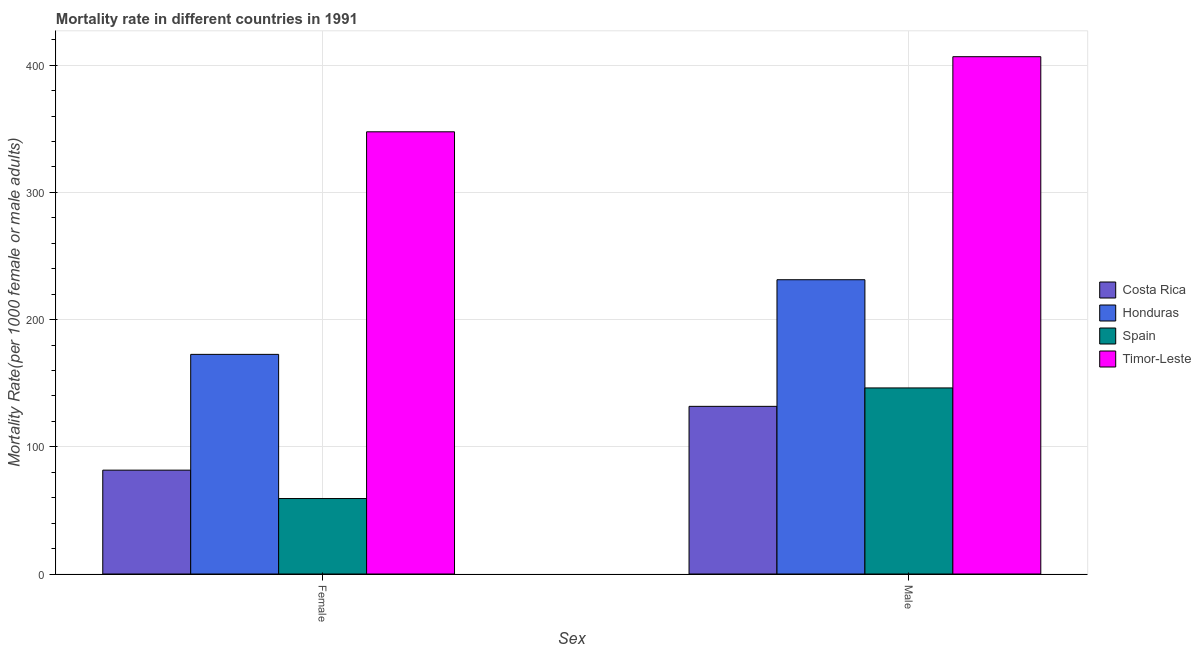How many groups of bars are there?
Your answer should be compact. 2. Are the number of bars on each tick of the X-axis equal?
Your response must be concise. Yes. How many bars are there on the 1st tick from the left?
Provide a succinct answer. 4. What is the male mortality rate in Costa Rica?
Make the answer very short. 131.81. Across all countries, what is the maximum female mortality rate?
Offer a very short reply. 347.65. Across all countries, what is the minimum female mortality rate?
Make the answer very short. 59.33. In which country was the male mortality rate maximum?
Your answer should be very brief. Timor-Leste. In which country was the male mortality rate minimum?
Your answer should be very brief. Costa Rica. What is the total male mortality rate in the graph?
Provide a succinct answer. 916.15. What is the difference between the female mortality rate in Spain and that in Honduras?
Keep it short and to the point. -113.35. What is the difference between the female mortality rate in Costa Rica and the male mortality rate in Spain?
Keep it short and to the point. -64.63. What is the average male mortality rate per country?
Make the answer very short. 229.04. What is the difference between the male mortality rate and female mortality rate in Costa Rica?
Your answer should be compact. 50.15. In how many countries, is the male mortality rate greater than 100 ?
Your response must be concise. 4. What is the ratio of the male mortality rate in Costa Rica to that in Honduras?
Offer a very short reply. 0.57. Is the female mortality rate in Timor-Leste less than that in Spain?
Your response must be concise. No. In how many countries, is the male mortality rate greater than the average male mortality rate taken over all countries?
Your response must be concise. 2. What does the 3rd bar from the right in Male represents?
Make the answer very short. Honduras. How many countries are there in the graph?
Offer a very short reply. 4. What is the difference between two consecutive major ticks on the Y-axis?
Keep it short and to the point. 100. Are the values on the major ticks of Y-axis written in scientific E-notation?
Your answer should be very brief. No. Does the graph contain grids?
Provide a short and direct response. Yes. How are the legend labels stacked?
Offer a terse response. Vertical. What is the title of the graph?
Your answer should be compact. Mortality rate in different countries in 1991. What is the label or title of the X-axis?
Offer a terse response. Sex. What is the label or title of the Y-axis?
Your answer should be very brief. Mortality Rate(per 1000 female or male adults). What is the Mortality Rate(per 1000 female or male adults) of Costa Rica in Female?
Provide a succinct answer. 81.65. What is the Mortality Rate(per 1000 female or male adults) in Honduras in Female?
Give a very brief answer. 172.67. What is the Mortality Rate(per 1000 female or male adults) in Spain in Female?
Your answer should be compact. 59.33. What is the Mortality Rate(per 1000 female or male adults) in Timor-Leste in Female?
Ensure brevity in your answer.  347.65. What is the Mortality Rate(per 1000 female or male adults) of Costa Rica in Male?
Offer a terse response. 131.81. What is the Mortality Rate(per 1000 female or male adults) in Honduras in Male?
Keep it short and to the point. 231.35. What is the Mortality Rate(per 1000 female or male adults) of Spain in Male?
Your response must be concise. 146.28. What is the Mortality Rate(per 1000 female or male adults) of Timor-Leste in Male?
Your response must be concise. 406.7. Across all Sex, what is the maximum Mortality Rate(per 1000 female or male adults) in Costa Rica?
Provide a succinct answer. 131.81. Across all Sex, what is the maximum Mortality Rate(per 1000 female or male adults) of Honduras?
Keep it short and to the point. 231.35. Across all Sex, what is the maximum Mortality Rate(per 1000 female or male adults) of Spain?
Ensure brevity in your answer.  146.28. Across all Sex, what is the maximum Mortality Rate(per 1000 female or male adults) in Timor-Leste?
Your answer should be compact. 406.7. Across all Sex, what is the minimum Mortality Rate(per 1000 female or male adults) of Costa Rica?
Ensure brevity in your answer.  81.65. Across all Sex, what is the minimum Mortality Rate(per 1000 female or male adults) of Honduras?
Your answer should be very brief. 172.67. Across all Sex, what is the minimum Mortality Rate(per 1000 female or male adults) in Spain?
Keep it short and to the point. 59.33. Across all Sex, what is the minimum Mortality Rate(per 1000 female or male adults) of Timor-Leste?
Your answer should be compact. 347.65. What is the total Mortality Rate(per 1000 female or male adults) of Costa Rica in the graph?
Your answer should be very brief. 213.46. What is the total Mortality Rate(per 1000 female or male adults) of Honduras in the graph?
Give a very brief answer. 404.02. What is the total Mortality Rate(per 1000 female or male adults) of Spain in the graph?
Your answer should be very brief. 205.61. What is the total Mortality Rate(per 1000 female or male adults) of Timor-Leste in the graph?
Keep it short and to the point. 754.35. What is the difference between the Mortality Rate(per 1000 female or male adults) of Costa Rica in Female and that in Male?
Provide a short and direct response. -50.16. What is the difference between the Mortality Rate(per 1000 female or male adults) of Honduras in Female and that in Male?
Offer a very short reply. -58.68. What is the difference between the Mortality Rate(per 1000 female or male adults) of Spain in Female and that in Male?
Ensure brevity in your answer.  -86.96. What is the difference between the Mortality Rate(per 1000 female or male adults) of Timor-Leste in Female and that in Male?
Your answer should be very brief. -59.06. What is the difference between the Mortality Rate(per 1000 female or male adults) of Costa Rica in Female and the Mortality Rate(per 1000 female or male adults) of Honduras in Male?
Give a very brief answer. -149.7. What is the difference between the Mortality Rate(per 1000 female or male adults) in Costa Rica in Female and the Mortality Rate(per 1000 female or male adults) in Spain in Male?
Ensure brevity in your answer.  -64.63. What is the difference between the Mortality Rate(per 1000 female or male adults) in Costa Rica in Female and the Mortality Rate(per 1000 female or male adults) in Timor-Leste in Male?
Provide a succinct answer. -325.05. What is the difference between the Mortality Rate(per 1000 female or male adults) in Honduras in Female and the Mortality Rate(per 1000 female or male adults) in Spain in Male?
Your answer should be compact. 26.39. What is the difference between the Mortality Rate(per 1000 female or male adults) of Honduras in Female and the Mortality Rate(per 1000 female or male adults) of Timor-Leste in Male?
Ensure brevity in your answer.  -234.03. What is the difference between the Mortality Rate(per 1000 female or male adults) in Spain in Female and the Mortality Rate(per 1000 female or male adults) in Timor-Leste in Male?
Ensure brevity in your answer.  -347.38. What is the average Mortality Rate(per 1000 female or male adults) of Costa Rica per Sex?
Your response must be concise. 106.73. What is the average Mortality Rate(per 1000 female or male adults) of Honduras per Sex?
Keep it short and to the point. 202.01. What is the average Mortality Rate(per 1000 female or male adults) of Spain per Sex?
Keep it short and to the point. 102.81. What is the average Mortality Rate(per 1000 female or male adults) in Timor-Leste per Sex?
Provide a short and direct response. 377.18. What is the difference between the Mortality Rate(per 1000 female or male adults) of Costa Rica and Mortality Rate(per 1000 female or male adults) of Honduras in Female?
Give a very brief answer. -91.02. What is the difference between the Mortality Rate(per 1000 female or male adults) of Costa Rica and Mortality Rate(per 1000 female or male adults) of Spain in Female?
Offer a very short reply. 22.33. What is the difference between the Mortality Rate(per 1000 female or male adults) in Costa Rica and Mortality Rate(per 1000 female or male adults) in Timor-Leste in Female?
Your response must be concise. -265.99. What is the difference between the Mortality Rate(per 1000 female or male adults) of Honduras and Mortality Rate(per 1000 female or male adults) of Spain in Female?
Offer a very short reply. 113.35. What is the difference between the Mortality Rate(per 1000 female or male adults) of Honduras and Mortality Rate(per 1000 female or male adults) of Timor-Leste in Female?
Ensure brevity in your answer.  -174.97. What is the difference between the Mortality Rate(per 1000 female or male adults) of Spain and Mortality Rate(per 1000 female or male adults) of Timor-Leste in Female?
Your answer should be compact. -288.32. What is the difference between the Mortality Rate(per 1000 female or male adults) of Costa Rica and Mortality Rate(per 1000 female or male adults) of Honduras in Male?
Ensure brevity in your answer.  -99.54. What is the difference between the Mortality Rate(per 1000 female or male adults) of Costa Rica and Mortality Rate(per 1000 female or male adults) of Spain in Male?
Provide a short and direct response. -14.48. What is the difference between the Mortality Rate(per 1000 female or male adults) of Costa Rica and Mortality Rate(per 1000 female or male adults) of Timor-Leste in Male?
Your answer should be very brief. -274.9. What is the difference between the Mortality Rate(per 1000 female or male adults) in Honduras and Mortality Rate(per 1000 female or male adults) in Spain in Male?
Provide a short and direct response. 85.07. What is the difference between the Mortality Rate(per 1000 female or male adults) in Honduras and Mortality Rate(per 1000 female or male adults) in Timor-Leste in Male?
Your response must be concise. -175.35. What is the difference between the Mortality Rate(per 1000 female or male adults) in Spain and Mortality Rate(per 1000 female or male adults) in Timor-Leste in Male?
Offer a terse response. -260.42. What is the ratio of the Mortality Rate(per 1000 female or male adults) of Costa Rica in Female to that in Male?
Your response must be concise. 0.62. What is the ratio of the Mortality Rate(per 1000 female or male adults) of Honduras in Female to that in Male?
Offer a terse response. 0.75. What is the ratio of the Mortality Rate(per 1000 female or male adults) in Spain in Female to that in Male?
Keep it short and to the point. 0.41. What is the ratio of the Mortality Rate(per 1000 female or male adults) in Timor-Leste in Female to that in Male?
Give a very brief answer. 0.85. What is the difference between the highest and the second highest Mortality Rate(per 1000 female or male adults) of Costa Rica?
Provide a short and direct response. 50.16. What is the difference between the highest and the second highest Mortality Rate(per 1000 female or male adults) of Honduras?
Provide a succinct answer. 58.68. What is the difference between the highest and the second highest Mortality Rate(per 1000 female or male adults) in Spain?
Give a very brief answer. 86.96. What is the difference between the highest and the second highest Mortality Rate(per 1000 female or male adults) in Timor-Leste?
Offer a terse response. 59.06. What is the difference between the highest and the lowest Mortality Rate(per 1000 female or male adults) in Costa Rica?
Give a very brief answer. 50.16. What is the difference between the highest and the lowest Mortality Rate(per 1000 female or male adults) in Honduras?
Make the answer very short. 58.68. What is the difference between the highest and the lowest Mortality Rate(per 1000 female or male adults) of Spain?
Offer a very short reply. 86.96. What is the difference between the highest and the lowest Mortality Rate(per 1000 female or male adults) in Timor-Leste?
Your response must be concise. 59.06. 